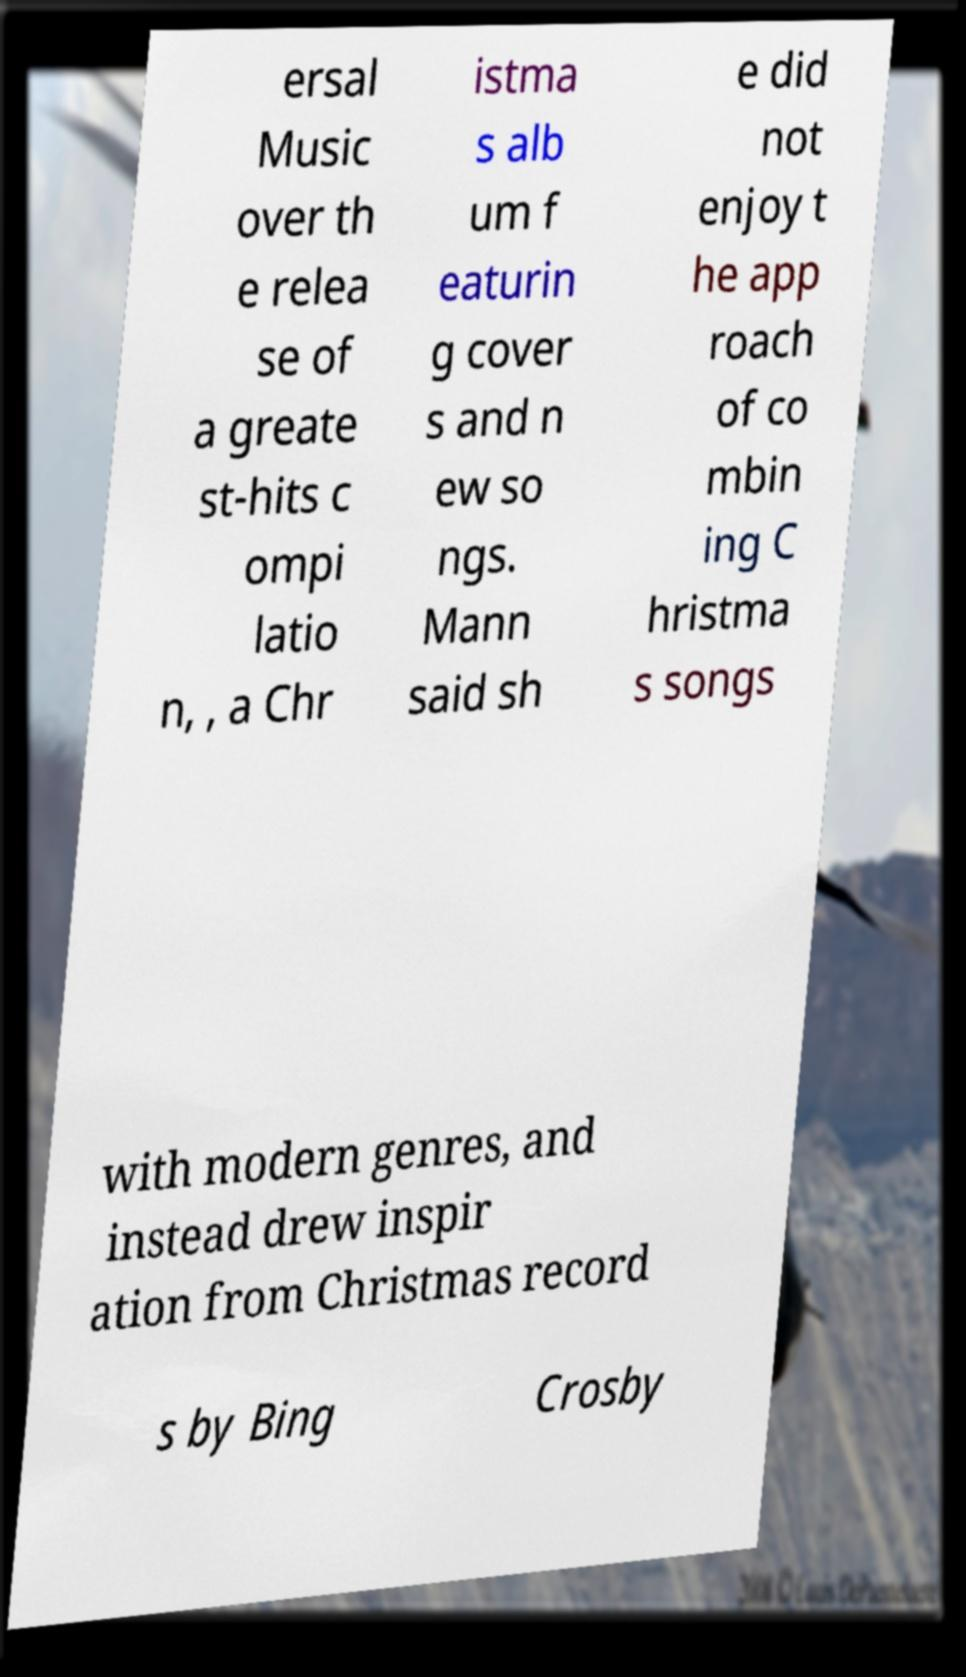What messages or text are displayed in this image? I need them in a readable, typed format. ersal Music over th e relea se of a greate st-hits c ompi latio n, , a Chr istma s alb um f eaturin g cover s and n ew so ngs. Mann said sh e did not enjoy t he app roach of co mbin ing C hristma s songs with modern genres, and instead drew inspir ation from Christmas record s by Bing Crosby 